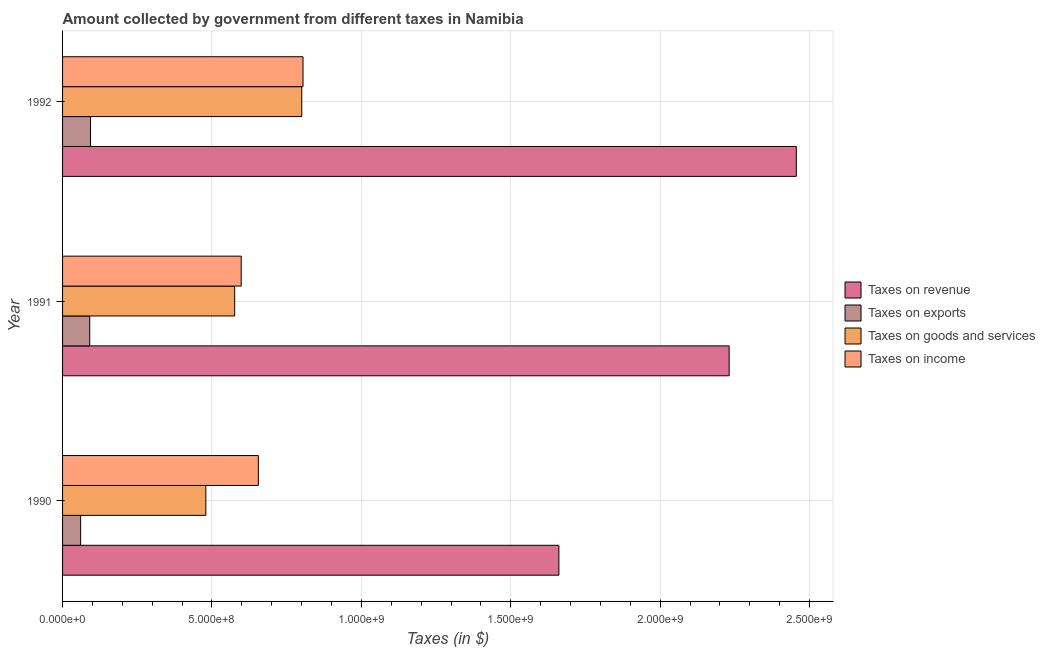How many different coloured bars are there?
Provide a short and direct response. 4. Are the number of bars per tick equal to the number of legend labels?
Your response must be concise. Yes. Are the number of bars on each tick of the Y-axis equal?
Your answer should be very brief. Yes. How many bars are there on the 2nd tick from the top?
Your answer should be very brief. 4. In how many cases, is the number of bars for a given year not equal to the number of legend labels?
Offer a terse response. 0. What is the amount collected as tax on revenue in 1991?
Give a very brief answer. 2.23e+09. Across all years, what is the maximum amount collected as tax on revenue?
Provide a succinct answer. 2.46e+09. Across all years, what is the minimum amount collected as tax on goods?
Your answer should be compact. 4.80e+08. In which year was the amount collected as tax on revenue minimum?
Keep it short and to the point. 1990. What is the total amount collected as tax on income in the graph?
Give a very brief answer. 2.06e+09. What is the difference between the amount collected as tax on exports in 1990 and that in 1992?
Ensure brevity in your answer.  -3.31e+07. What is the difference between the amount collected as tax on revenue in 1991 and the amount collected as tax on exports in 1990?
Ensure brevity in your answer.  2.17e+09. What is the average amount collected as tax on exports per year?
Offer a very short reply. 8.17e+07. In the year 1992, what is the difference between the amount collected as tax on income and amount collected as tax on revenue?
Offer a terse response. -1.65e+09. What is the ratio of the amount collected as tax on exports in 1991 to that in 1992?
Offer a terse response. 0.97. Is the amount collected as tax on revenue in 1990 less than that in 1991?
Keep it short and to the point. Yes. What is the difference between the highest and the second highest amount collected as tax on revenue?
Ensure brevity in your answer.  2.25e+08. What is the difference between the highest and the lowest amount collected as tax on income?
Give a very brief answer. 2.07e+08. In how many years, is the amount collected as tax on income greater than the average amount collected as tax on income taken over all years?
Offer a very short reply. 1. Is it the case that in every year, the sum of the amount collected as tax on exports and amount collected as tax on income is greater than the sum of amount collected as tax on goods and amount collected as tax on revenue?
Provide a short and direct response. No. What does the 1st bar from the top in 1990 represents?
Keep it short and to the point. Taxes on income. What does the 1st bar from the bottom in 1991 represents?
Give a very brief answer. Taxes on revenue. How many years are there in the graph?
Provide a succinct answer. 3. Are the values on the major ticks of X-axis written in scientific E-notation?
Offer a terse response. Yes. Does the graph contain grids?
Make the answer very short. Yes. How are the legend labels stacked?
Make the answer very short. Vertical. What is the title of the graph?
Make the answer very short. Amount collected by government from different taxes in Namibia. What is the label or title of the X-axis?
Make the answer very short. Taxes (in $). What is the Taxes (in $) of Taxes on revenue in 1990?
Offer a terse response. 1.66e+09. What is the Taxes (in $) of Taxes on exports in 1990?
Make the answer very short. 6.05e+07. What is the Taxes (in $) of Taxes on goods and services in 1990?
Keep it short and to the point. 4.80e+08. What is the Taxes (in $) in Taxes on income in 1990?
Provide a short and direct response. 6.55e+08. What is the Taxes (in $) of Taxes on revenue in 1991?
Your answer should be very brief. 2.23e+09. What is the Taxes (in $) in Taxes on exports in 1991?
Your response must be concise. 9.09e+07. What is the Taxes (in $) of Taxes on goods and services in 1991?
Give a very brief answer. 5.76e+08. What is the Taxes (in $) in Taxes on income in 1991?
Make the answer very short. 5.98e+08. What is the Taxes (in $) in Taxes on revenue in 1992?
Provide a short and direct response. 2.46e+09. What is the Taxes (in $) in Taxes on exports in 1992?
Your answer should be compact. 9.36e+07. What is the Taxes (in $) in Taxes on goods and services in 1992?
Ensure brevity in your answer.  8.00e+08. What is the Taxes (in $) of Taxes on income in 1992?
Offer a terse response. 8.05e+08. Across all years, what is the maximum Taxes (in $) of Taxes on revenue?
Make the answer very short. 2.46e+09. Across all years, what is the maximum Taxes (in $) in Taxes on exports?
Offer a terse response. 9.36e+07. Across all years, what is the maximum Taxes (in $) of Taxes on goods and services?
Make the answer very short. 8.00e+08. Across all years, what is the maximum Taxes (in $) of Taxes on income?
Keep it short and to the point. 8.05e+08. Across all years, what is the minimum Taxes (in $) in Taxes on revenue?
Keep it short and to the point. 1.66e+09. Across all years, what is the minimum Taxes (in $) of Taxes on exports?
Provide a short and direct response. 6.05e+07. Across all years, what is the minimum Taxes (in $) of Taxes on goods and services?
Your response must be concise. 4.80e+08. Across all years, what is the minimum Taxes (in $) in Taxes on income?
Offer a terse response. 5.98e+08. What is the total Taxes (in $) in Taxes on revenue in the graph?
Your answer should be very brief. 6.35e+09. What is the total Taxes (in $) in Taxes on exports in the graph?
Your answer should be compact. 2.45e+08. What is the total Taxes (in $) of Taxes on goods and services in the graph?
Offer a terse response. 1.86e+09. What is the total Taxes (in $) of Taxes on income in the graph?
Offer a very short reply. 2.06e+09. What is the difference between the Taxes (in $) in Taxes on revenue in 1990 and that in 1991?
Offer a very short reply. -5.70e+08. What is the difference between the Taxes (in $) in Taxes on exports in 1990 and that in 1991?
Offer a terse response. -3.04e+07. What is the difference between the Taxes (in $) in Taxes on goods and services in 1990 and that in 1991?
Provide a short and direct response. -9.65e+07. What is the difference between the Taxes (in $) in Taxes on income in 1990 and that in 1991?
Your answer should be very brief. 5.74e+07. What is the difference between the Taxes (in $) in Taxes on revenue in 1990 and that in 1992?
Your answer should be compact. -7.95e+08. What is the difference between the Taxes (in $) of Taxes on exports in 1990 and that in 1992?
Make the answer very short. -3.31e+07. What is the difference between the Taxes (in $) of Taxes on goods and services in 1990 and that in 1992?
Give a very brief answer. -3.21e+08. What is the difference between the Taxes (in $) in Taxes on income in 1990 and that in 1992?
Keep it short and to the point. -1.50e+08. What is the difference between the Taxes (in $) of Taxes on revenue in 1991 and that in 1992?
Your answer should be very brief. -2.25e+08. What is the difference between the Taxes (in $) in Taxes on exports in 1991 and that in 1992?
Ensure brevity in your answer.  -2.70e+06. What is the difference between the Taxes (in $) in Taxes on goods and services in 1991 and that in 1992?
Give a very brief answer. -2.24e+08. What is the difference between the Taxes (in $) in Taxes on income in 1991 and that in 1992?
Give a very brief answer. -2.07e+08. What is the difference between the Taxes (in $) of Taxes on revenue in 1990 and the Taxes (in $) of Taxes on exports in 1991?
Your answer should be compact. 1.57e+09. What is the difference between the Taxes (in $) of Taxes on revenue in 1990 and the Taxes (in $) of Taxes on goods and services in 1991?
Your response must be concise. 1.08e+09. What is the difference between the Taxes (in $) of Taxes on revenue in 1990 and the Taxes (in $) of Taxes on income in 1991?
Offer a very short reply. 1.06e+09. What is the difference between the Taxes (in $) in Taxes on exports in 1990 and the Taxes (in $) in Taxes on goods and services in 1991?
Offer a terse response. -5.16e+08. What is the difference between the Taxes (in $) in Taxes on exports in 1990 and the Taxes (in $) in Taxes on income in 1991?
Your answer should be compact. -5.37e+08. What is the difference between the Taxes (in $) in Taxes on goods and services in 1990 and the Taxes (in $) in Taxes on income in 1991?
Your answer should be very brief. -1.18e+08. What is the difference between the Taxes (in $) of Taxes on revenue in 1990 and the Taxes (in $) of Taxes on exports in 1992?
Keep it short and to the point. 1.57e+09. What is the difference between the Taxes (in $) of Taxes on revenue in 1990 and the Taxes (in $) of Taxes on goods and services in 1992?
Your response must be concise. 8.60e+08. What is the difference between the Taxes (in $) of Taxes on revenue in 1990 and the Taxes (in $) of Taxes on income in 1992?
Your answer should be very brief. 8.56e+08. What is the difference between the Taxes (in $) in Taxes on exports in 1990 and the Taxes (in $) in Taxes on goods and services in 1992?
Your answer should be very brief. -7.40e+08. What is the difference between the Taxes (in $) of Taxes on exports in 1990 and the Taxes (in $) of Taxes on income in 1992?
Make the answer very short. -7.44e+08. What is the difference between the Taxes (in $) in Taxes on goods and services in 1990 and the Taxes (in $) in Taxes on income in 1992?
Keep it short and to the point. -3.25e+08. What is the difference between the Taxes (in $) of Taxes on revenue in 1991 and the Taxes (in $) of Taxes on exports in 1992?
Offer a very short reply. 2.14e+09. What is the difference between the Taxes (in $) in Taxes on revenue in 1991 and the Taxes (in $) in Taxes on goods and services in 1992?
Provide a short and direct response. 1.43e+09. What is the difference between the Taxes (in $) of Taxes on revenue in 1991 and the Taxes (in $) of Taxes on income in 1992?
Your answer should be very brief. 1.43e+09. What is the difference between the Taxes (in $) of Taxes on exports in 1991 and the Taxes (in $) of Taxes on goods and services in 1992?
Offer a terse response. -7.10e+08. What is the difference between the Taxes (in $) in Taxes on exports in 1991 and the Taxes (in $) in Taxes on income in 1992?
Provide a succinct answer. -7.14e+08. What is the difference between the Taxes (in $) of Taxes on goods and services in 1991 and the Taxes (in $) of Taxes on income in 1992?
Offer a terse response. -2.29e+08. What is the average Taxes (in $) of Taxes on revenue per year?
Make the answer very short. 2.12e+09. What is the average Taxes (in $) in Taxes on exports per year?
Offer a very short reply. 8.17e+07. What is the average Taxes (in $) of Taxes on goods and services per year?
Make the answer very short. 6.19e+08. What is the average Taxes (in $) of Taxes on income per year?
Your answer should be compact. 6.86e+08. In the year 1990, what is the difference between the Taxes (in $) in Taxes on revenue and Taxes (in $) in Taxes on exports?
Provide a succinct answer. 1.60e+09. In the year 1990, what is the difference between the Taxes (in $) in Taxes on revenue and Taxes (in $) in Taxes on goods and services?
Provide a short and direct response. 1.18e+09. In the year 1990, what is the difference between the Taxes (in $) of Taxes on revenue and Taxes (in $) of Taxes on income?
Your answer should be very brief. 1.01e+09. In the year 1990, what is the difference between the Taxes (in $) of Taxes on exports and Taxes (in $) of Taxes on goods and services?
Your answer should be very brief. -4.19e+08. In the year 1990, what is the difference between the Taxes (in $) in Taxes on exports and Taxes (in $) in Taxes on income?
Provide a short and direct response. -5.95e+08. In the year 1990, what is the difference between the Taxes (in $) of Taxes on goods and services and Taxes (in $) of Taxes on income?
Ensure brevity in your answer.  -1.76e+08. In the year 1991, what is the difference between the Taxes (in $) in Taxes on revenue and Taxes (in $) in Taxes on exports?
Keep it short and to the point. 2.14e+09. In the year 1991, what is the difference between the Taxes (in $) in Taxes on revenue and Taxes (in $) in Taxes on goods and services?
Your answer should be very brief. 1.65e+09. In the year 1991, what is the difference between the Taxes (in $) in Taxes on revenue and Taxes (in $) in Taxes on income?
Keep it short and to the point. 1.63e+09. In the year 1991, what is the difference between the Taxes (in $) of Taxes on exports and Taxes (in $) of Taxes on goods and services?
Make the answer very short. -4.85e+08. In the year 1991, what is the difference between the Taxes (in $) in Taxes on exports and Taxes (in $) in Taxes on income?
Give a very brief answer. -5.07e+08. In the year 1991, what is the difference between the Taxes (in $) in Taxes on goods and services and Taxes (in $) in Taxes on income?
Your response must be concise. -2.18e+07. In the year 1992, what is the difference between the Taxes (in $) in Taxes on revenue and Taxes (in $) in Taxes on exports?
Make the answer very short. 2.36e+09. In the year 1992, what is the difference between the Taxes (in $) in Taxes on revenue and Taxes (in $) in Taxes on goods and services?
Your response must be concise. 1.66e+09. In the year 1992, what is the difference between the Taxes (in $) of Taxes on revenue and Taxes (in $) of Taxes on income?
Your answer should be very brief. 1.65e+09. In the year 1992, what is the difference between the Taxes (in $) in Taxes on exports and Taxes (in $) in Taxes on goods and services?
Keep it short and to the point. -7.07e+08. In the year 1992, what is the difference between the Taxes (in $) in Taxes on exports and Taxes (in $) in Taxes on income?
Offer a very short reply. -7.11e+08. In the year 1992, what is the difference between the Taxes (in $) in Taxes on goods and services and Taxes (in $) in Taxes on income?
Offer a very short reply. -4.20e+06. What is the ratio of the Taxes (in $) of Taxes on revenue in 1990 to that in 1991?
Ensure brevity in your answer.  0.74. What is the ratio of the Taxes (in $) of Taxes on exports in 1990 to that in 1991?
Your answer should be compact. 0.67. What is the ratio of the Taxes (in $) in Taxes on goods and services in 1990 to that in 1991?
Your response must be concise. 0.83. What is the ratio of the Taxes (in $) of Taxes on income in 1990 to that in 1991?
Your response must be concise. 1.1. What is the ratio of the Taxes (in $) of Taxes on revenue in 1990 to that in 1992?
Keep it short and to the point. 0.68. What is the ratio of the Taxes (in $) of Taxes on exports in 1990 to that in 1992?
Your response must be concise. 0.65. What is the ratio of the Taxes (in $) of Taxes on goods and services in 1990 to that in 1992?
Provide a succinct answer. 0.6. What is the ratio of the Taxes (in $) of Taxes on income in 1990 to that in 1992?
Offer a very short reply. 0.81. What is the ratio of the Taxes (in $) in Taxes on revenue in 1991 to that in 1992?
Provide a short and direct response. 0.91. What is the ratio of the Taxes (in $) of Taxes on exports in 1991 to that in 1992?
Keep it short and to the point. 0.97. What is the ratio of the Taxes (in $) in Taxes on goods and services in 1991 to that in 1992?
Offer a very short reply. 0.72. What is the ratio of the Taxes (in $) of Taxes on income in 1991 to that in 1992?
Offer a terse response. 0.74. What is the difference between the highest and the second highest Taxes (in $) in Taxes on revenue?
Your answer should be compact. 2.25e+08. What is the difference between the highest and the second highest Taxes (in $) in Taxes on exports?
Your answer should be very brief. 2.70e+06. What is the difference between the highest and the second highest Taxes (in $) of Taxes on goods and services?
Offer a very short reply. 2.24e+08. What is the difference between the highest and the second highest Taxes (in $) in Taxes on income?
Your answer should be very brief. 1.50e+08. What is the difference between the highest and the lowest Taxes (in $) in Taxes on revenue?
Your answer should be compact. 7.95e+08. What is the difference between the highest and the lowest Taxes (in $) in Taxes on exports?
Make the answer very short. 3.31e+07. What is the difference between the highest and the lowest Taxes (in $) in Taxes on goods and services?
Make the answer very short. 3.21e+08. What is the difference between the highest and the lowest Taxes (in $) in Taxes on income?
Provide a short and direct response. 2.07e+08. 